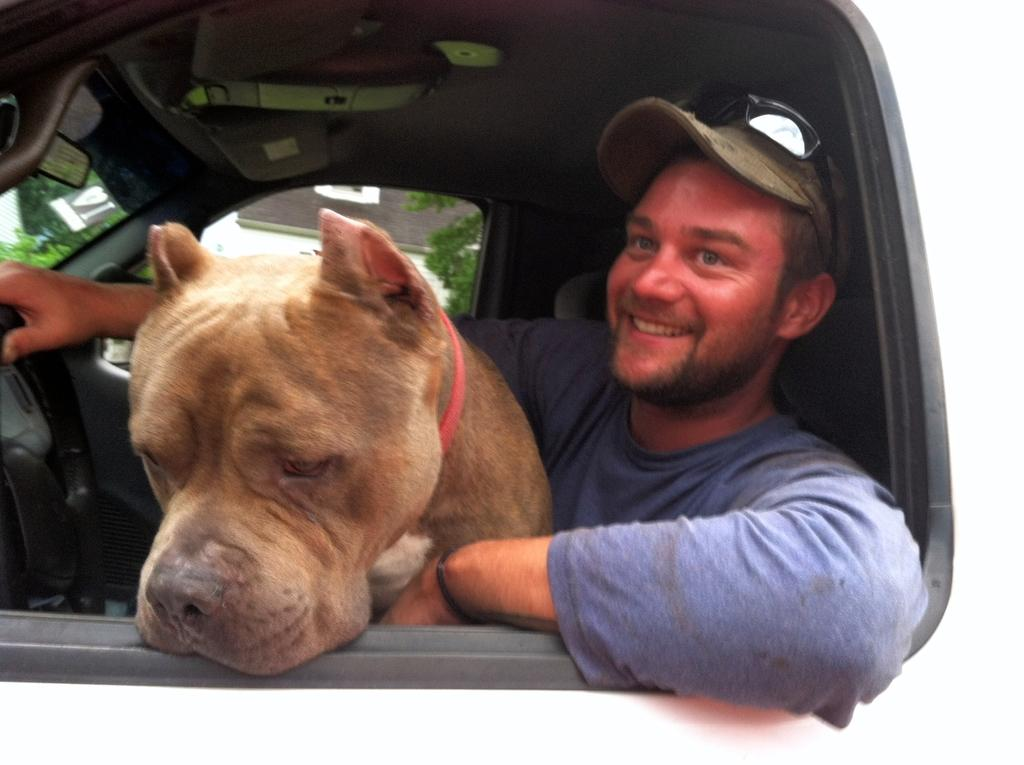Who is present in the image? There is a man in the image. What is the man doing in the image? The man is sitting in a car. Is there any other living creature in the image besides the man? Yes, there is a dog in the image. How is the dog positioned in relation to the man? The dog is on the man. Can you see the man and the dog swimming together in the image? No, there is no swimming activity depicted in the image; the man is sitting in a car, and the dog is on the man. 